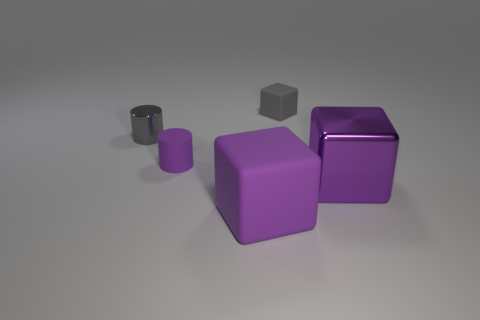Add 2 purple metallic cubes. How many objects exist? 7 Subtract all cubes. How many objects are left? 2 Add 1 large objects. How many large objects are left? 3 Add 5 large red metal objects. How many large red metal objects exist? 5 Subtract 0 blue cubes. How many objects are left? 5 Subtract all purple rubber cylinders. Subtract all large brown cylinders. How many objects are left? 4 